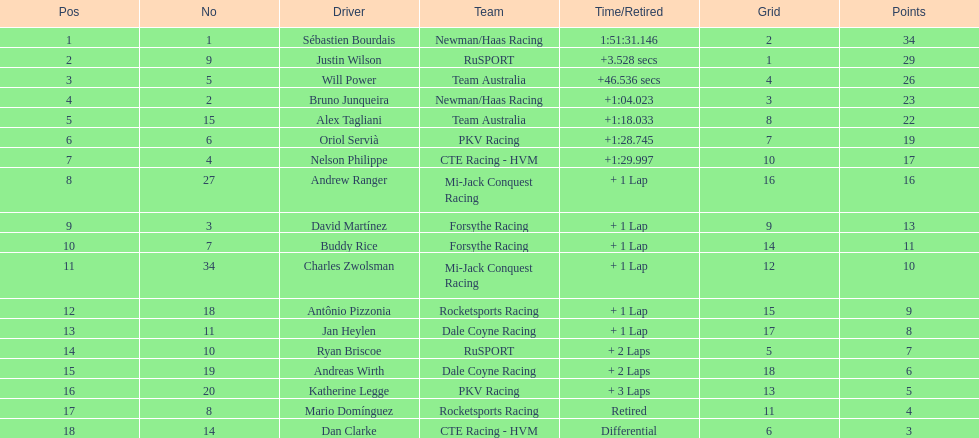How many drivers did not make more than 60 laps? 2. 